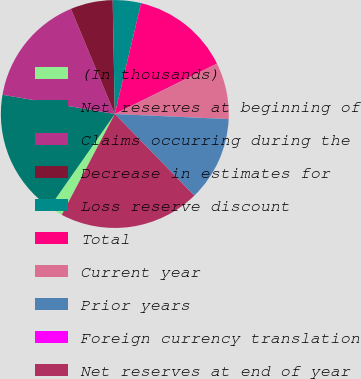Convert chart to OTSL. <chart><loc_0><loc_0><loc_500><loc_500><pie_chart><fcel>(In thousands)<fcel>Net reserves at beginning of<fcel>Claims occurring during the<fcel>Decrease in estimates for<fcel>Loss reserve discount<fcel>Total<fcel>Current year<fcel>Prior years<fcel>Foreign currency translation<fcel>Net reserves at end of year<nl><fcel>2.0%<fcel>18.0%<fcel>16.0%<fcel>6.0%<fcel>4.0%<fcel>14.0%<fcel>8.0%<fcel>12.0%<fcel>0.0%<fcel>20.0%<nl></chart> 